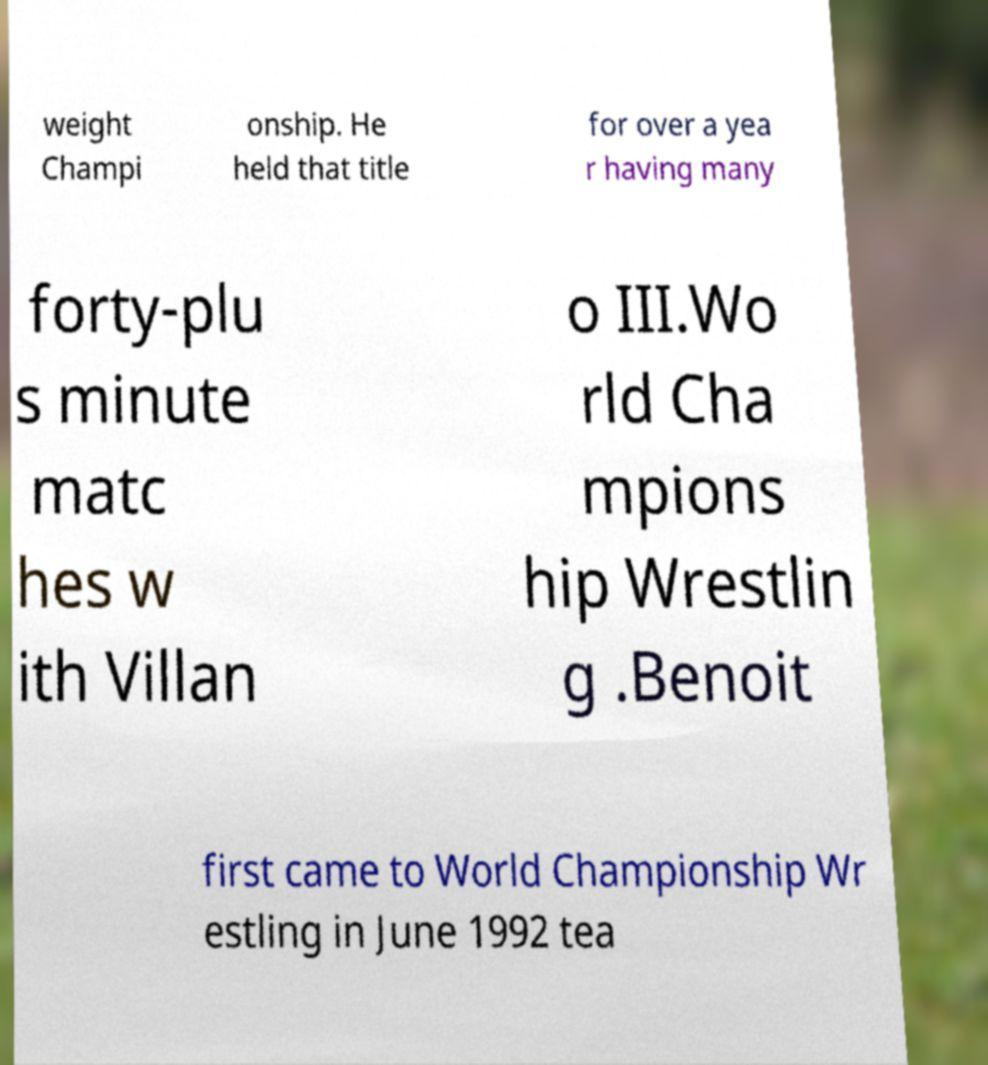Can you accurately transcribe the text from the provided image for me? weight Champi onship. He held that title for over a yea r having many forty-plu s minute matc hes w ith Villan o III.Wo rld Cha mpions hip Wrestlin g .Benoit first came to World Championship Wr estling in June 1992 tea 